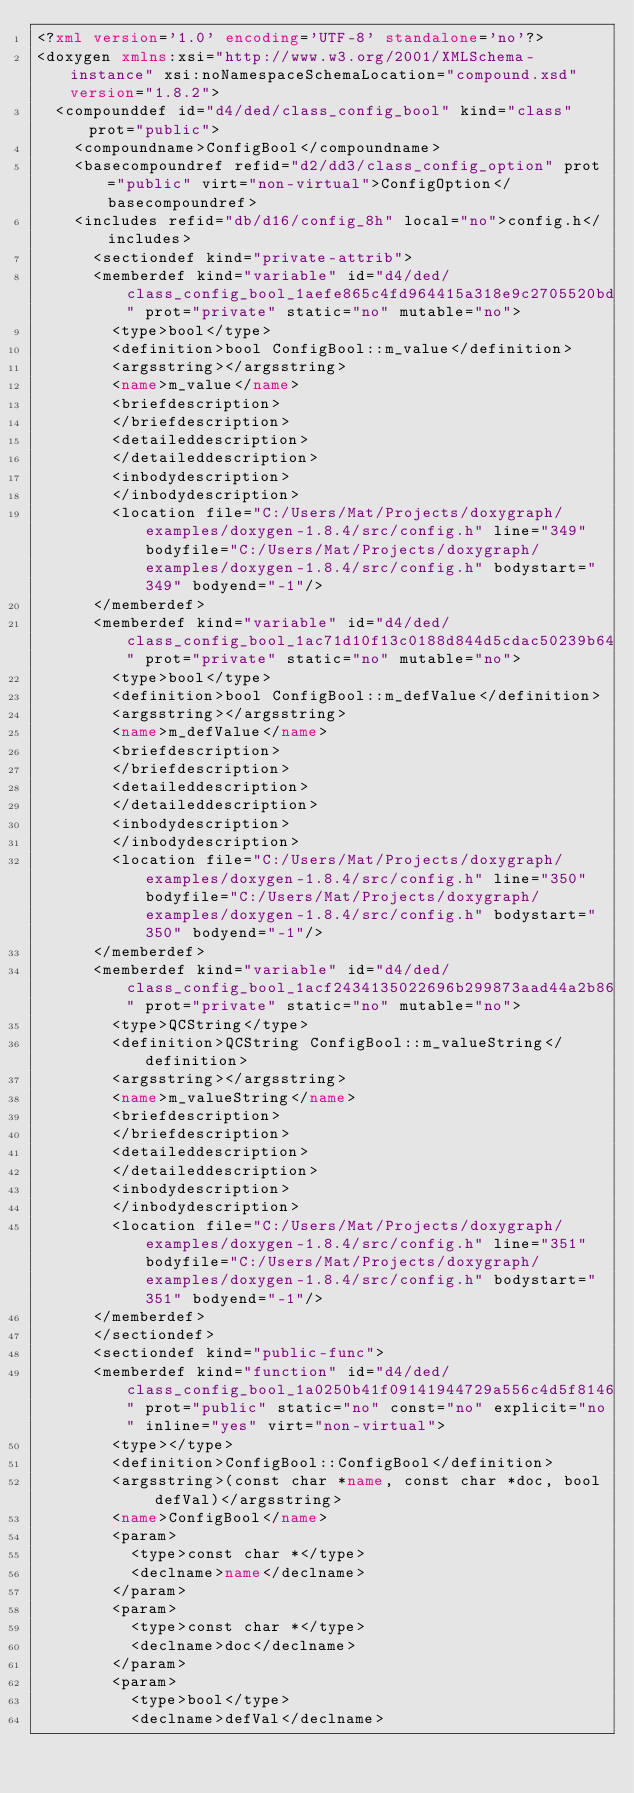<code> <loc_0><loc_0><loc_500><loc_500><_XML_><?xml version='1.0' encoding='UTF-8' standalone='no'?>
<doxygen xmlns:xsi="http://www.w3.org/2001/XMLSchema-instance" xsi:noNamespaceSchemaLocation="compound.xsd" version="1.8.2">
  <compounddef id="d4/ded/class_config_bool" kind="class" prot="public">
    <compoundname>ConfigBool</compoundname>
    <basecompoundref refid="d2/dd3/class_config_option" prot="public" virt="non-virtual">ConfigOption</basecompoundref>
    <includes refid="db/d16/config_8h" local="no">config.h</includes>
      <sectiondef kind="private-attrib">
      <memberdef kind="variable" id="d4/ded/class_config_bool_1aefe865c4fd964415a318e9c2705520bd" prot="private" static="no" mutable="no">
        <type>bool</type>
        <definition>bool ConfigBool::m_value</definition>
        <argsstring></argsstring>
        <name>m_value</name>
        <briefdescription>
        </briefdescription>
        <detaileddescription>
        </detaileddescription>
        <inbodydescription>
        </inbodydescription>
        <location file="C:/Users/Mat/Projects/doxygraph/examples/doxygen-1.8.4/src/config.h" line="349" bodyfile="C:/Users/Mat/Projects/doxygraph/examples/doxygen-1.8.4/src/config.h" bodystart="349" bodyend="-1"/>
      </memberdef>
      <memberdef kind="variable" id="d4/ded/class_config_bool_1ac71d10f13c0188d844d5cdac50239b64" prot="private" static="no" mutable="no">
        <type>bool</type>
        <definition>bool ConfigBool::m_defValue</definition>
        <argsstring></argsstring>
        <name>m_defValue</name>
        <briefdescription>
        </briefdescription>
        <detaileddescription>
        </detaileddescription>
        <inbodydescription>
        </inbodydescription>
        <location file="C:/Users/Mat/Projects/doxygraph/examples/doxygen-1.8.4/src/config.h" line="350" bodyfile="C:/Users/Mat/Projects/doxygraph/examples/doxygen-1.8.4/src/config.h" bodystart="350" bodyend="-1"/>
      </memberdef>
      <memberdef kind="variable" id="d4/ded/class_config_bool_1acf2434135022696b299873aad44a2b86" prot="private" static="no" mutable="no">
        <type>QCString</type>
        <definition>QCString ConfigBool::m_valueString</definition>
        <argsstring></argsstring>
        <name>m_valueString</name>
        <briefdescription>
        </briefdescription>
        <detaileddescription>
        </detaileddescription>
        <inbodydescription>
        </inbodydescription>
        <location file="C:/Users/Mat/Projects/doxygraph/examples/doxygen-1.8.4/src/config.h" line="351" bodyfile="C:/Users/Mat/Projects/doxygraph/examples/doxygen-1.8.4/src/config.h" bodystart="351" bodyend="-1"/>
      </memberdef>
      </sectiondef>
      <sectiondef kind="public-func">
      <memberdef kind="function" id="d4/ded/class_config_bool_1a0250b41f09141944729a556c4d5f8146" prot="public" static="no" const="no" explicit="no" inline="yes" virt="non-virtual">
        <type></type>
        <definition>ConfigBool::ConfigBool</definition>
        <argsstring>(const char *name, const char *doc, bool defVal)</argsstring>
        <name>ConfigBool</name>
        <param>
          <type>const char *</type>
          <declname>name</declname>
        </param>
        <param>
          <type>const char *</type>
          <declname>doc</declname>
        </param>
        <param>
          <type>bool</type>
          <declname>defVal</declname></code> 